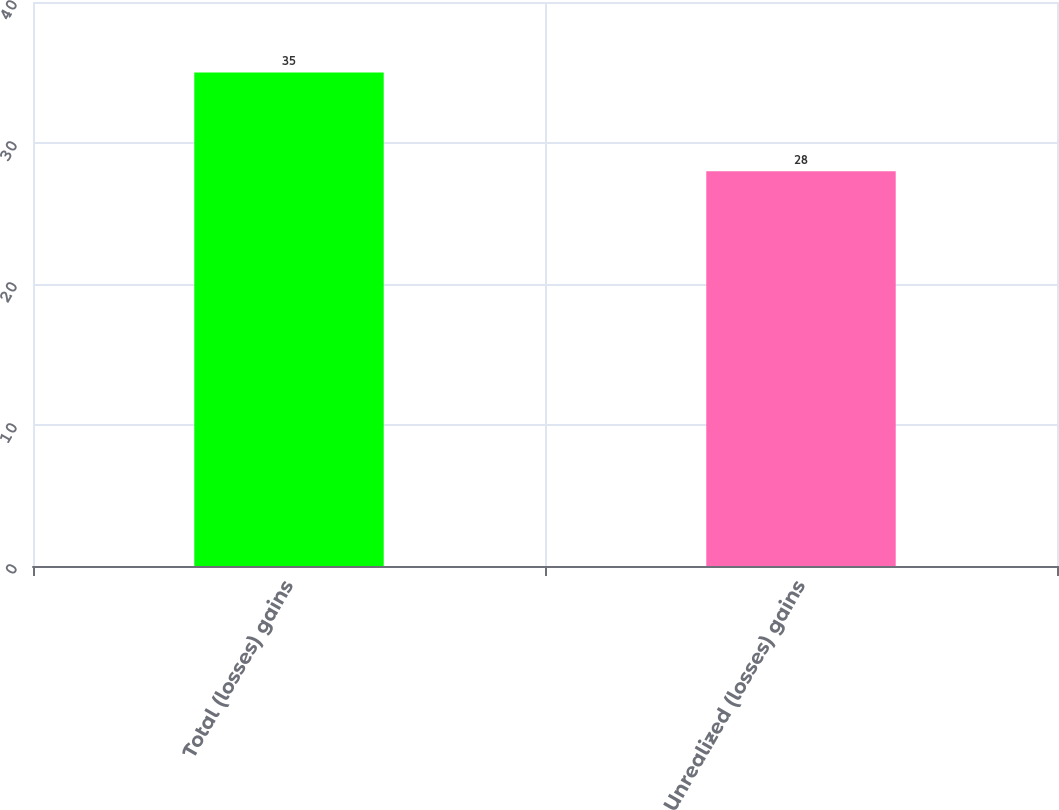<chart> <loc_0><loc_0><loc_500><loc_500><bar_chart><fcel>Total (losses) gains<fcel>Unrealized (losses) gains<nl><fcel>35<fcel>28<nl></chart> 